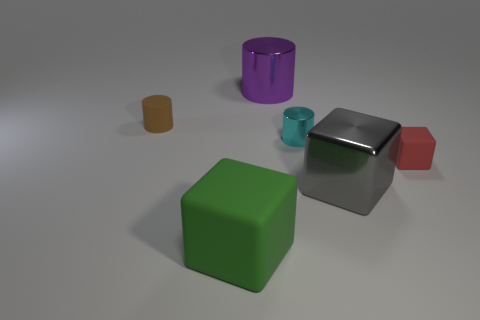Does the rubber object right of the green rubber object have the same shape as the small thing that is to the left of the cyan metal cylinder?
Provide a short and direct response. No. There is a purple cylinder; are there any tiny metallic cylinders left of it?
Your response must be concise. No. There is another small metal object that is the same shape as the brown object; what color is it?
Your answer should be compact. Cyan. What material is the big cube that is on the left side of the purple shiny cylinder?
Make the answer very short. Rubber. There is a red thing that is the same shape as the green object; what is its size?
Your answer should be compact. Small. What number of purple things are made of the same material as the green block?
Keep it short and to the point. 0. What number of tiny objects have the same color as the shiny block?
Ensure brevity in your answer.  0. How many objects are either blocks right of the green rubber thing or metallic objects that are behind the tiny brown rubber object?
Your answer should be compact. 3. Is the number of large purple objects that are behind the tiny matte cube less than the number of big green cylinders?
Provide a short and direct response. No. Is there a blue matte block that has the same size as the brown cylinder?
Your response must be concise. No. 